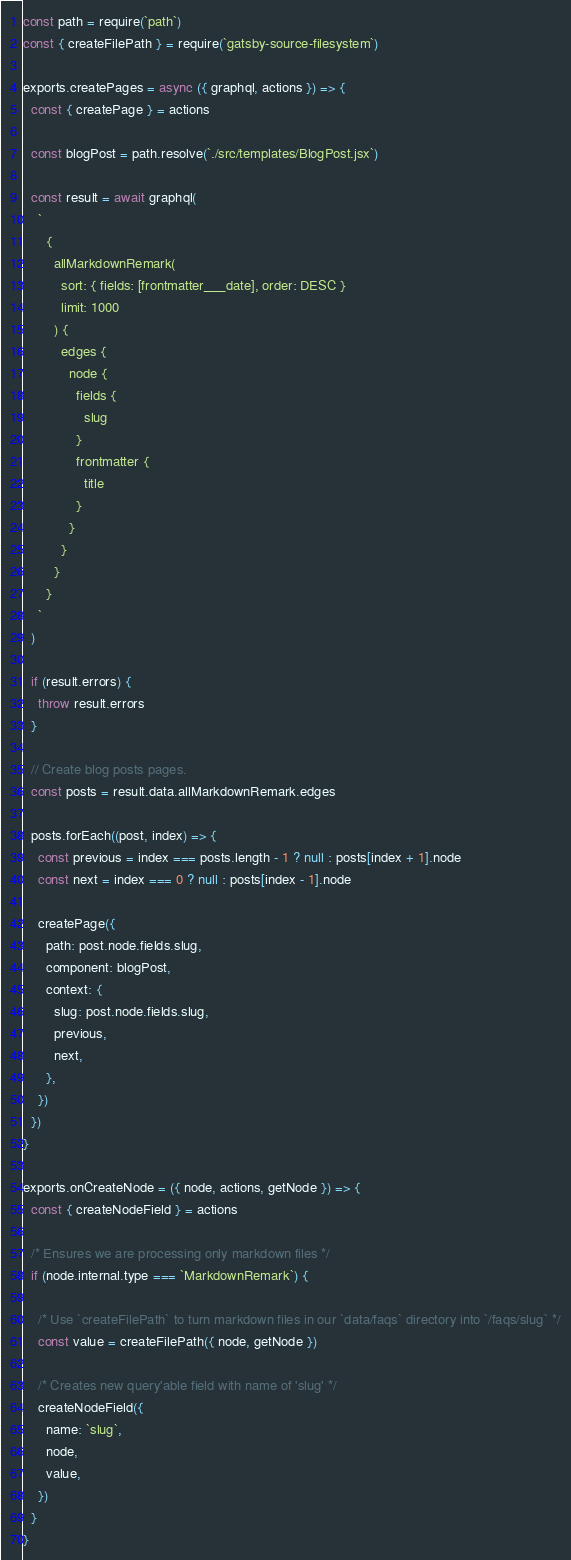<code> <loc_0><loc_0><loc_500><loc_500><_JavaScript_>const path = require(`path`)
const { createFilePath } = require(`gatsby-source-filesystem`)

exports.createPages = async ({ graphql, actions }) => {
  const { createPage } = actions

  const blogPost = path.resolve(`./src/templates/BlogPost.jsx`)

  const result = await graphql(
    `
      {
        allMarkdownRemark(
          sort: { fields: [frontmatter___date], order: DESC }
          limit: 1000
        ) {
          edges {
            node {
              fields {
                slug
              }
              frontmatter {
                title
              }
            }
          }
        }
      }
    `
  )

  if (result.errors) {
    throw result.errors
  }

  // Create blog posts pages.
  const posts = result.data.allMarkdownRemark.edges

  posts.forEach((post, index) => {
    const previous = index === posts.length - 1 ? null : posts[index + 1].node
    const next = index === 0 ? null : posts[index - 1].node

    createPage({
      path: post.node.fields.slug,
      component: blogPost,
      context: {
        slug: post.node.fields.slug,
        previous,
        next,
      },
    })
  })
}

exports.onCreateNode = ({ node, actions, getNode }) => {
  const { createNodeField } = actions

  /* Ensures we are processing only markdown files */
  if (node.internal.type === `MarkdownRemark`) {

    /* Use `createFilePath` to turn markdown files in our `data/faqs` directory into `/faqs/slug` */
    const value = createFilePath({ node, getNode })

    /* Creates new query'able field with name of 'slug' */
    createNodeField({
      name: `slug`,
      node,
      value,
    })
  }
}
</code> 